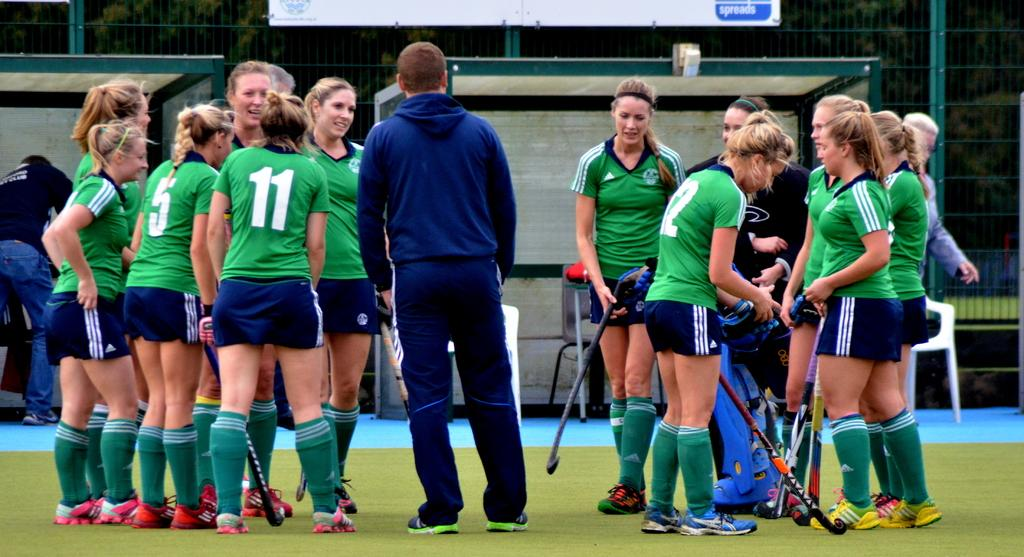<image>
Summarize the visual content of the image. A group of female hockey players with the number 5, 11, and 12 on their shirts are standing around on the field. 